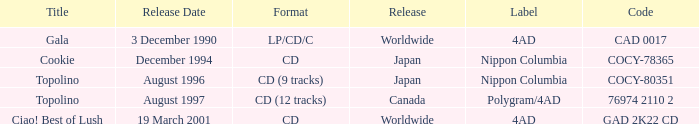What Label released an album in August 1996? Nippon Columbia. 